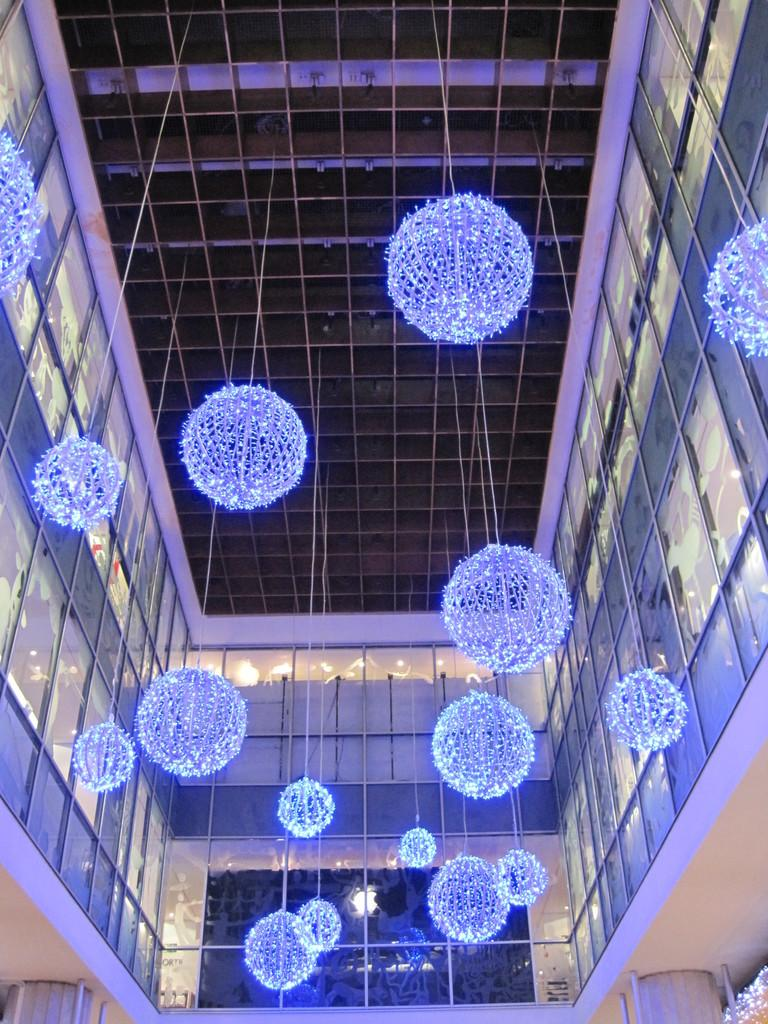What type of material is used for the windows in the image? The windows in the image are made of glass. What can be seen hanging from the ceiling in the image? Decorative lights are hanging from the ceiling in the image. What type of celery dish is being prepared in the image? There is no celery or any indication of food preparation in the image; it only features glass windows and decorative lights hanging from the ceiling. 